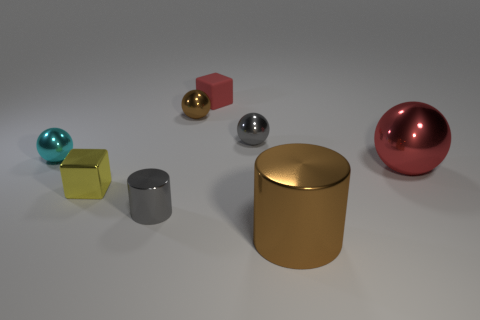Subtract all cyan balls. How many balls are left? 3 Subtract all red balls. How many balls are left? 3 Subtract all yellow balls. Subtract all green blocks. How many balls are left? 4 Add 1 large shiny blocks. How many objects exist? 9 Subtract all cubes. How many objects are left? 6 Subtract 0 green cylinders. How many objects are left? 8 Subtract all large brown objects. Subtract all small things. How many objects are left? 1 Add 5 tiny cyan metallic balls. How many tiny cyan metallic balls are left? 6 Add 3 green rubber cylinders. How many green rubber cylinders exist? 3 